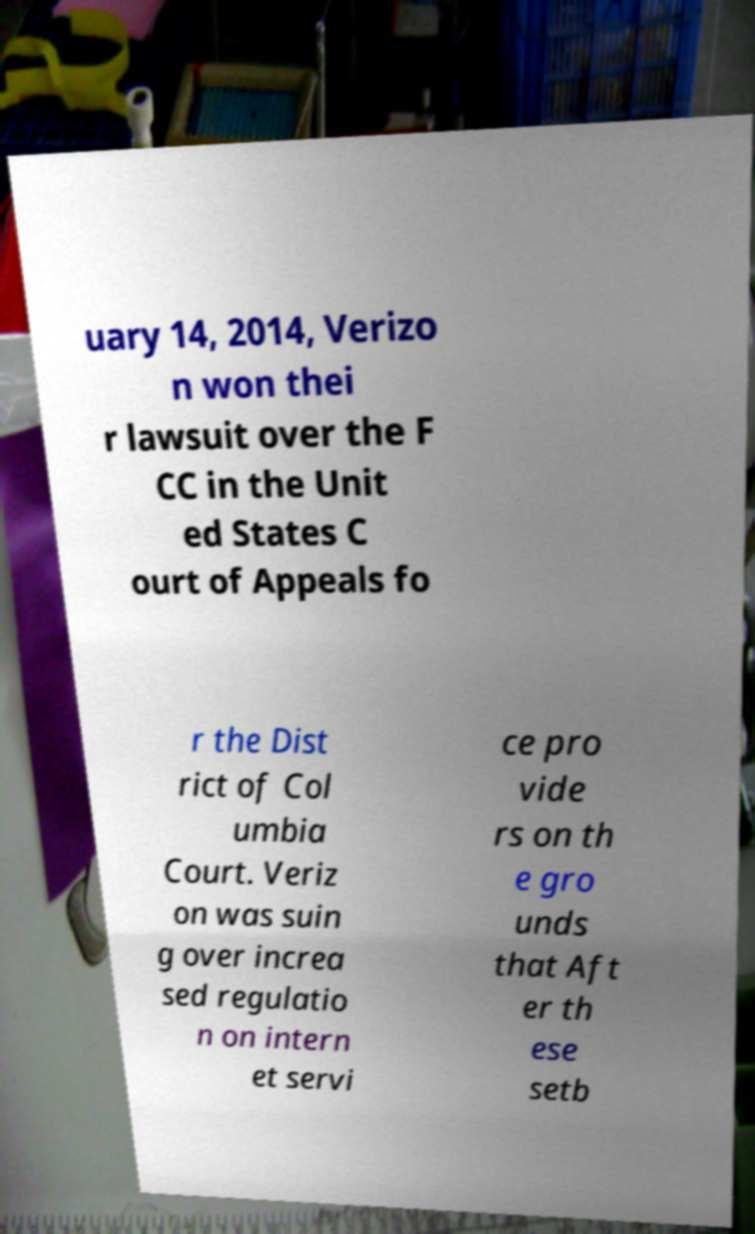There's text embedded in this image that I need extracted. Can you transcribe it verbatim? uary 14, 2014, Verizo n won thei r lawsuit over the F CC in the Unit ed States C ourt of Appeals fo r the Dist rict of Col umbia Court. Veriz on was suin g over increa sed regulatio n on intern et servi ce pro vide rs on th e gro unds that Aft er th ese setb 